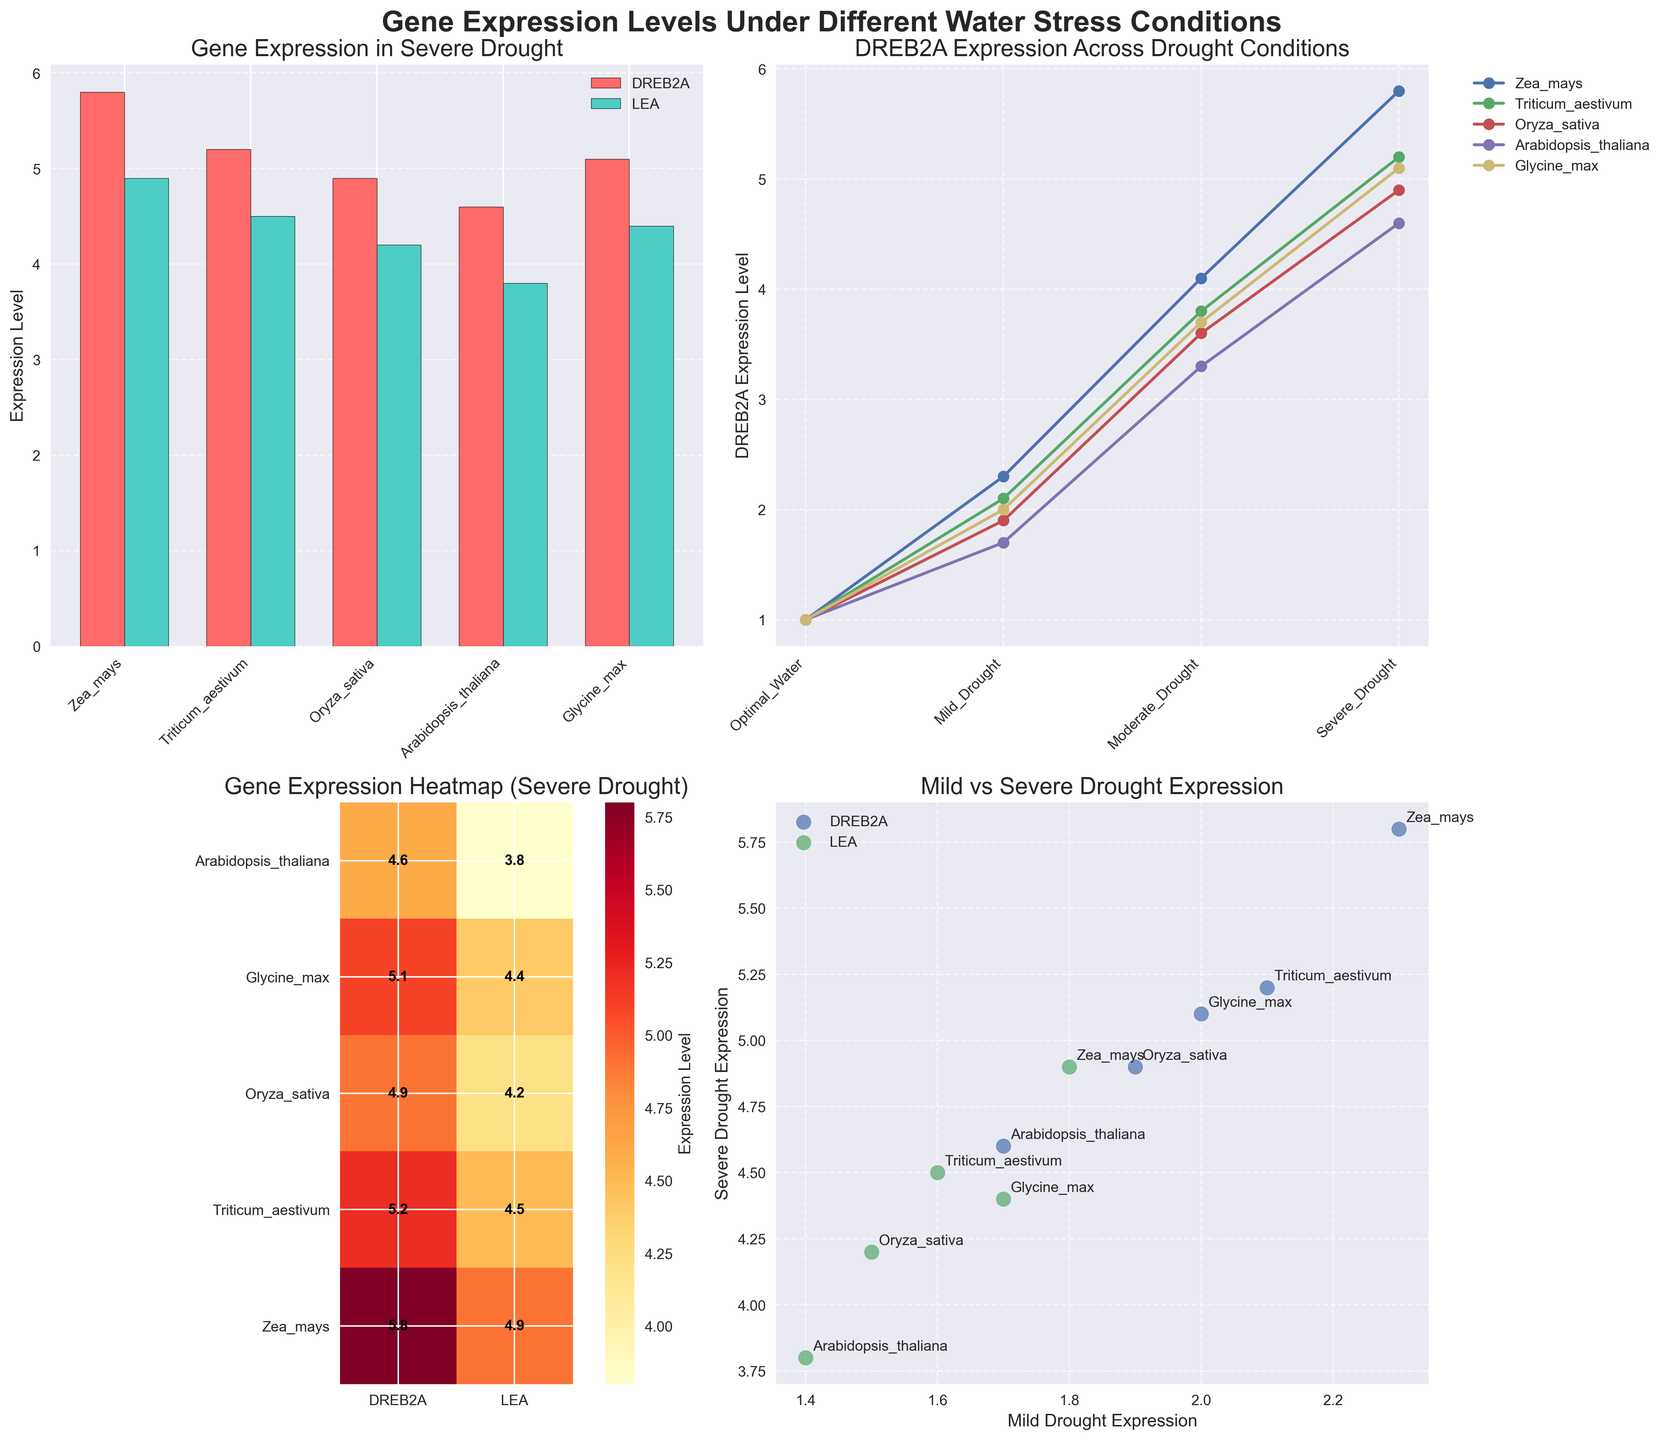Which plant species has the highest expression level of the DREB2A gene under severe drought? From the bar plot for gene expression in severe drought, the DREB2A gene is represented by red bars. The tallest red bar corresponds to Zea mays.
Answer: Zea mays In the line plot, which plant species shows the steepest increase in DREB2A expression level from optimal water to severe drought? By examining the slopes in the line plot, Zea mays (corn) exhibits the steepest increase from optimal water condition to severe drought.
Answer: Zea mays According to the heatmap, which plant species shows the lowest severe drought expression level for the LEA gene? The heatmap indicates expression levels for severe drought by gene and species. The smallest value for LEA (among the green areas) is found for Arabidopsis thaliana.
Answer: Arabidopsis thaliana How does the expression level of the LEA gene in mild drought compare to severe drought for Triticum aestivum? From the scatter plot, one can compare the LEA gene points for Triticum aestivum, identifying that severe drought has a slightly higher value compared to mild drought.
Answer: Higher in severe drought From the scatter plot, which gene shows a more consistent increase in expression levels from mild to severe drought among all species? Both DREB2A and LEA can be compared in the scatter plot. DREB2A points demonstrate a consistent and generally linear increase, while LEA points show a bit more scatter.
Answer: DREB2A 